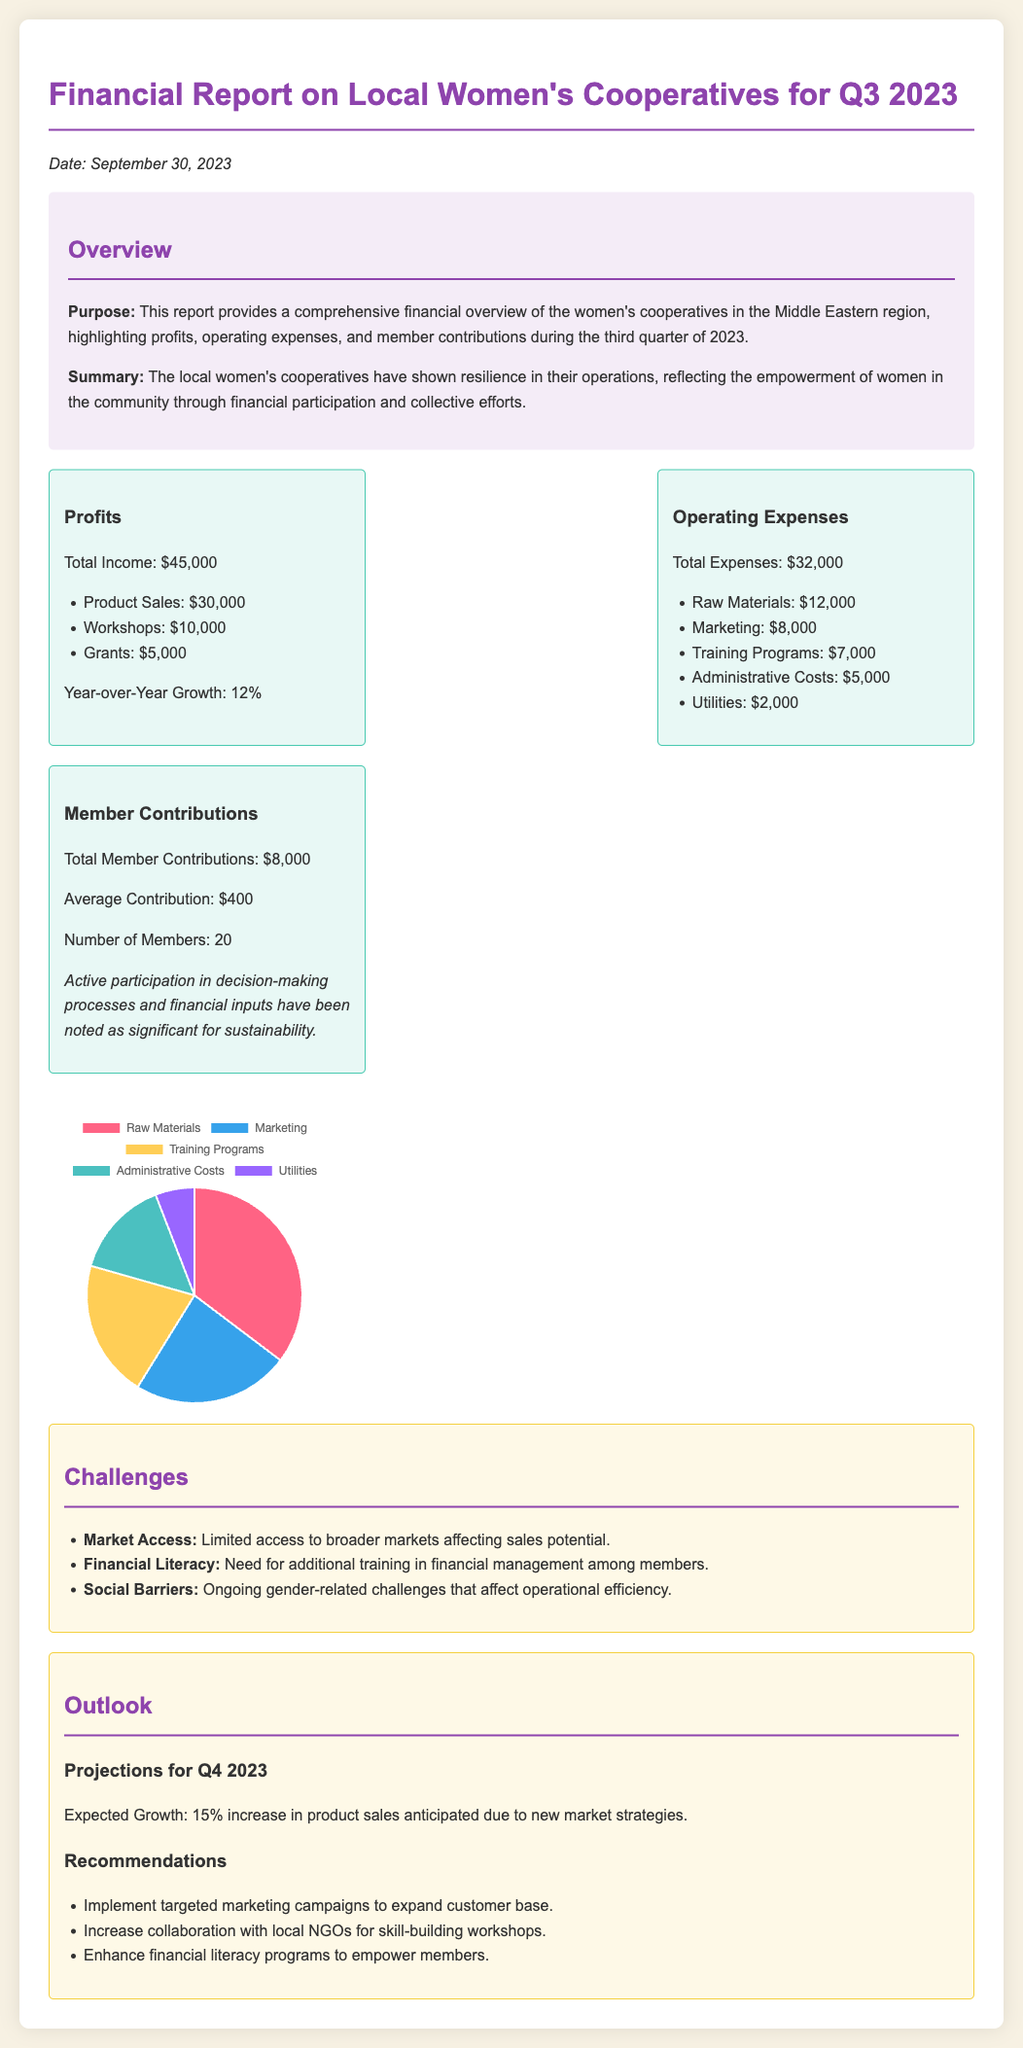What is the total income for Q3 2023? The total income is stated directly in the document under profits, totaling $45,000.
Answer: $45,000 What are the total operating expenses? The document clearly states the total operating expenses which is $32,000.
Answer: $32,000 What is the average member contribution? The average contribution is specified in the member contributions section as $400.
Answer: $400 What was the year-over-year growth? The year-over-year growth mentioned in the profits section is 12%.
Answer: 12% What are the anticipated expected growth for Q4 2023? The expected growth for Q4 2023 is noted to be a 15% increase in product sales.
Answer: 15% What is the most significant challenge mentioned in the report? Among the challenges listed, "Market Access" is the most significant issue highlighted.
Answer: Market Access How many active members contributed? The number of members who contributed is mentioned as 20 in the member contributions section.
Answer: 20 What was the income from workshops? The income from workshops is detailed as $10,000 in the profits section.
Answer: $10,000 What is the total amount spent on marketing? The total amount spent on marketing is listed in the operating expenses as $8,000.
Answer: $8,000 